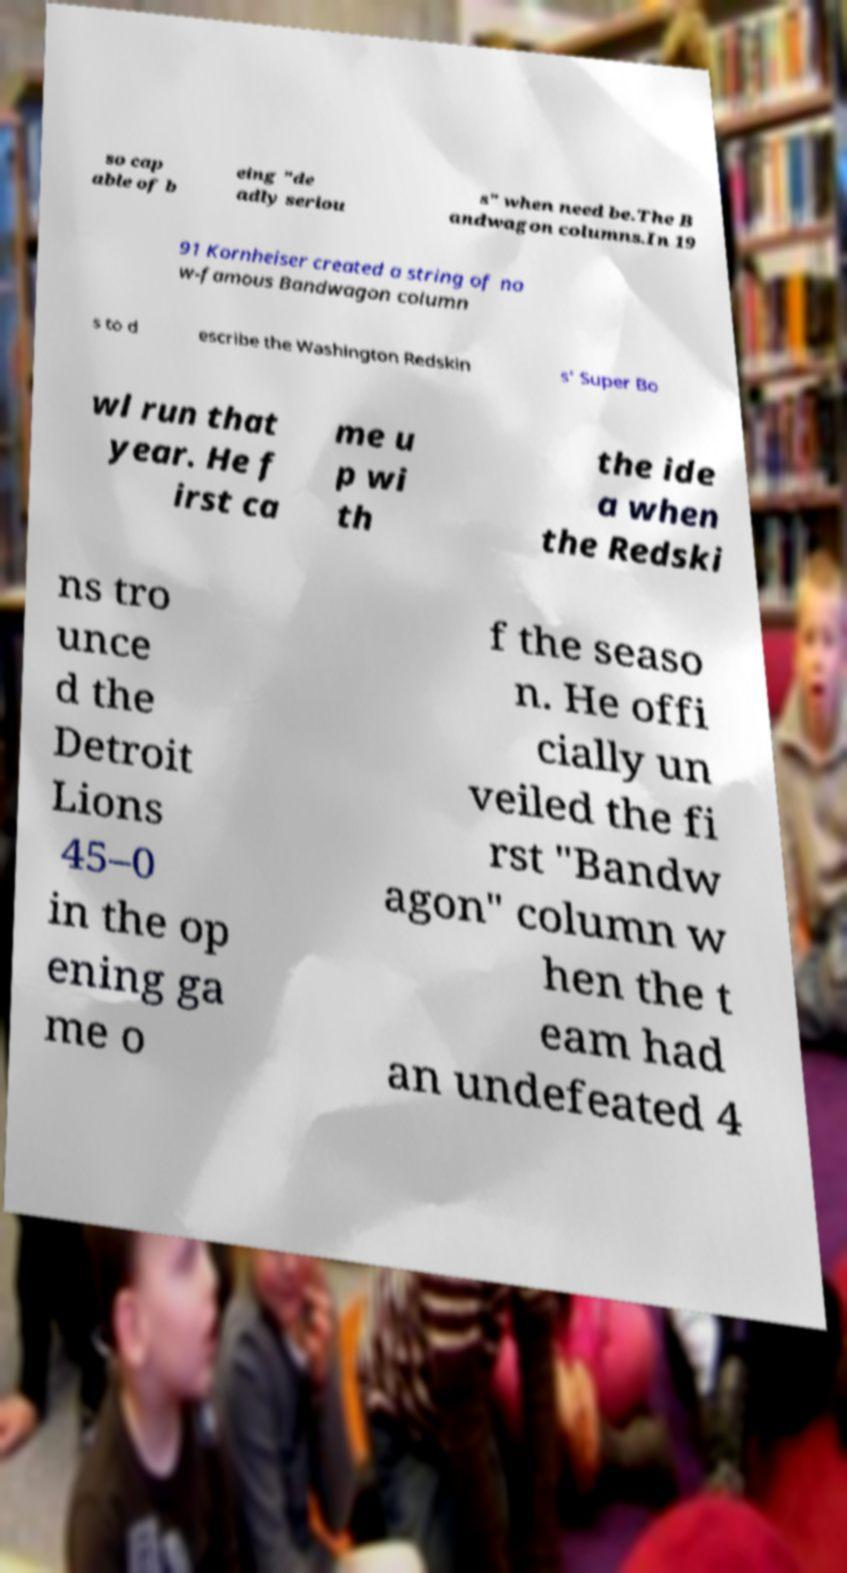Could you extract and type out the text from this image? so cap able of b eing "de adly seriou s" when need be.The B andwagon columns.In 19 91 Kornheiser created a string of no w-famous Bandwagon column s to d escribe the Washington Redskin s' Super Bo wl run that year. He f irst ca me u p wi th the ide a when the Redski ns tro unce d the Detroit Lions 45–0 in the op ening ga me o f the seaso n. He offi cially un veiled the fi rst "Bandw agon" column w hen the t eam had an undefeated 4 